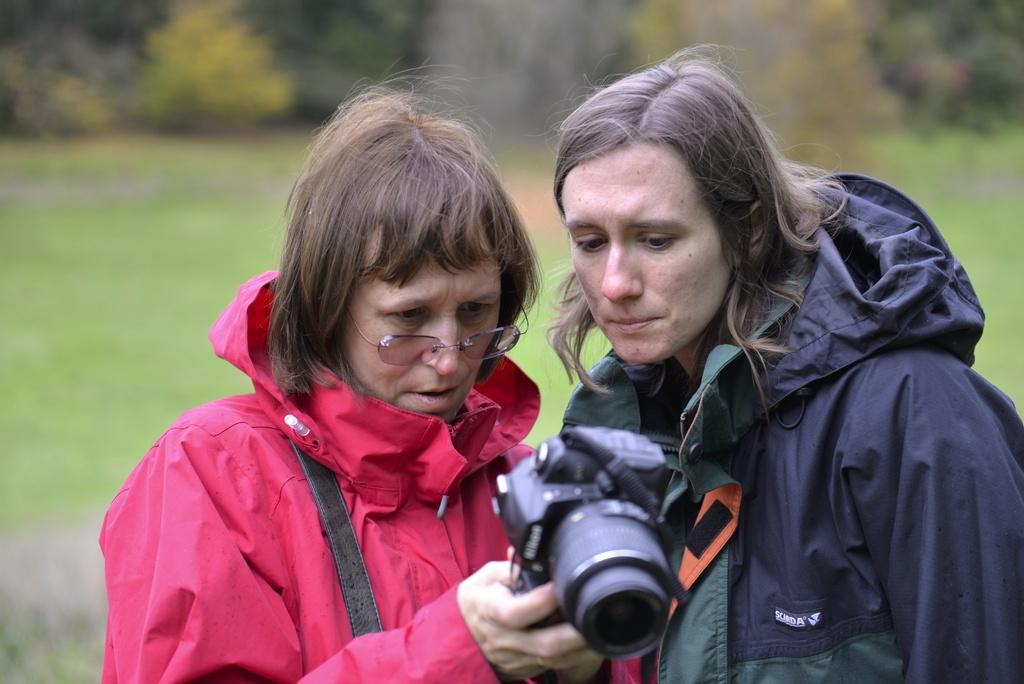How many women are in the image? There are two women standing in the image. What is the woman in the pink jacket wearing? The woman in the pink jacket is wearing a pink jacket. What is the woman in the pink jacket holding? The woman in the pink jacket is holding a camera. What type of ground is visible in the image? There is grass on the ground in the image. What can be seen in the background of the image? There are plants in the background of the image. Can you tell me how many cacti are visible in the image? There are no cacti visible in the image; only plants are present in the background. Are the two women in the image fighting or jumping? There is no indication of fighting or jumping in the image; the women are simply standing. 